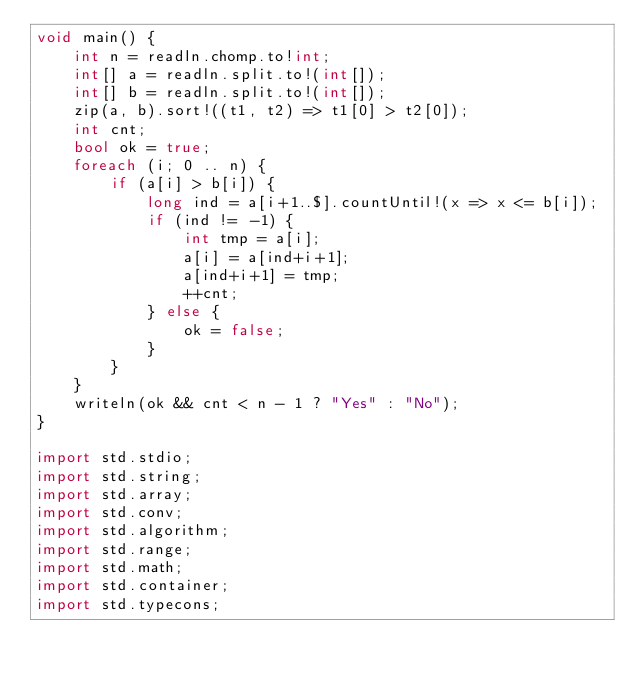<code> <loc_0><loc_0><loc_500><loc_500><_D_>void main() {
    int n = readln.chomp.to!int;
    int[] a = readln.split.to!(int[]);
    int[] b = readln.split.to!(int[]);
    zip(a, b).sort!((t1, t2) => t1[0] > t2[0]);
    int cnt;
    bool ok = true;
    foreach (i; 0 .. n) {
        if (a[i] > b[i]) {
            long ind = a[i+1..$].countUntil!(x => x <= b[i]);
            if (ind != -1) {
                int tmp = a[i];
                a[i] = a[ind+i+1];
                a[ind+i+1] = tmp;
                ++cnt;
            } else {
                ok = false;
            }
        }
    }
    writeln(ok && cnt < n - 1 ? "Yes" : "No");
}

import std.stdio;
import std.string;
import std.array;
import std.conv;
import std.algorithm;
import std.range;
import std.math;
import std.container;
import std.typecons;</code> 